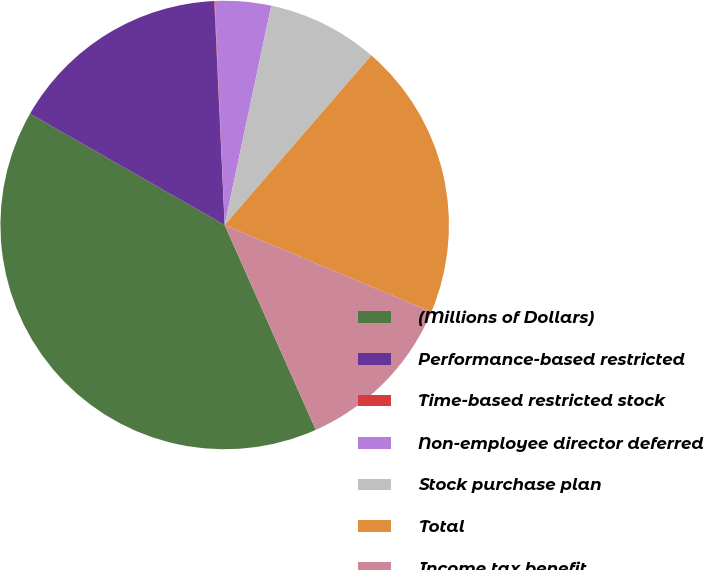Convert chart. <chart><loc_0><loc_0><loc_500><loc_500><pie_chart><fcel>(Millions of Dollars)<fcel>Performance-based restricted<fcel>Time-based restricted stock<fcel>Non-employee director deferred<fcel>Stock purchase plan<fcel>Total<fcel>Income tax benefit<nl><fcel>39.93%<fcel>16.0%<fcel>0.04%<fcel>4.03%<fcel>8.02%<fcel>19.98%<fcel>12.01%<nl></chart> 